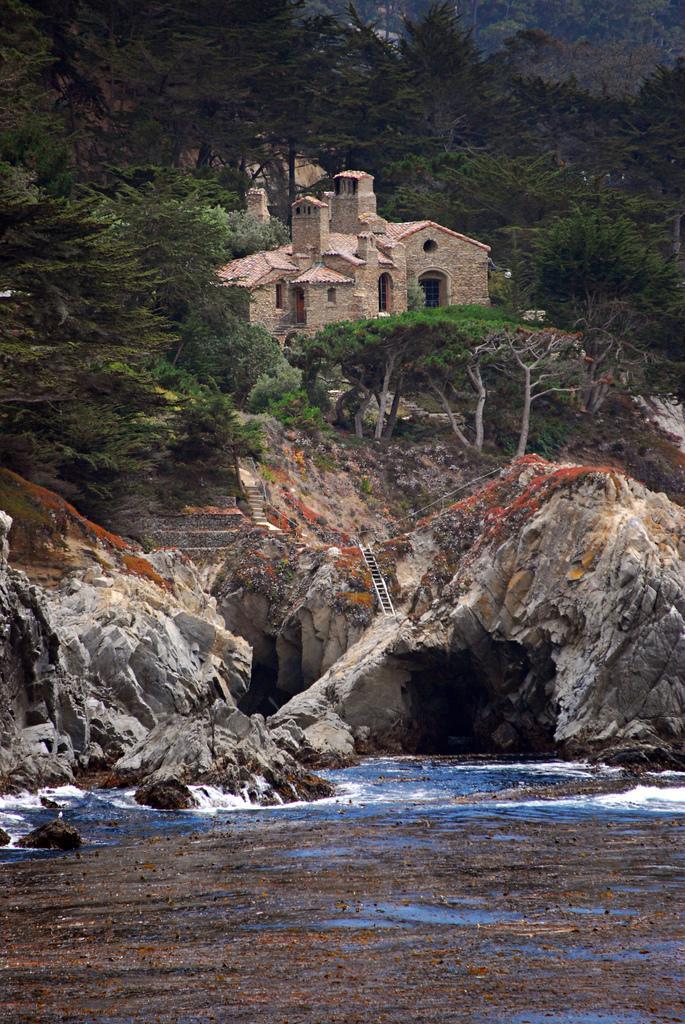Please provide a concise description of this image. In this image at the bottom there is a river, and in the background there are some rocks, ladder, trees and some houses and plants. 